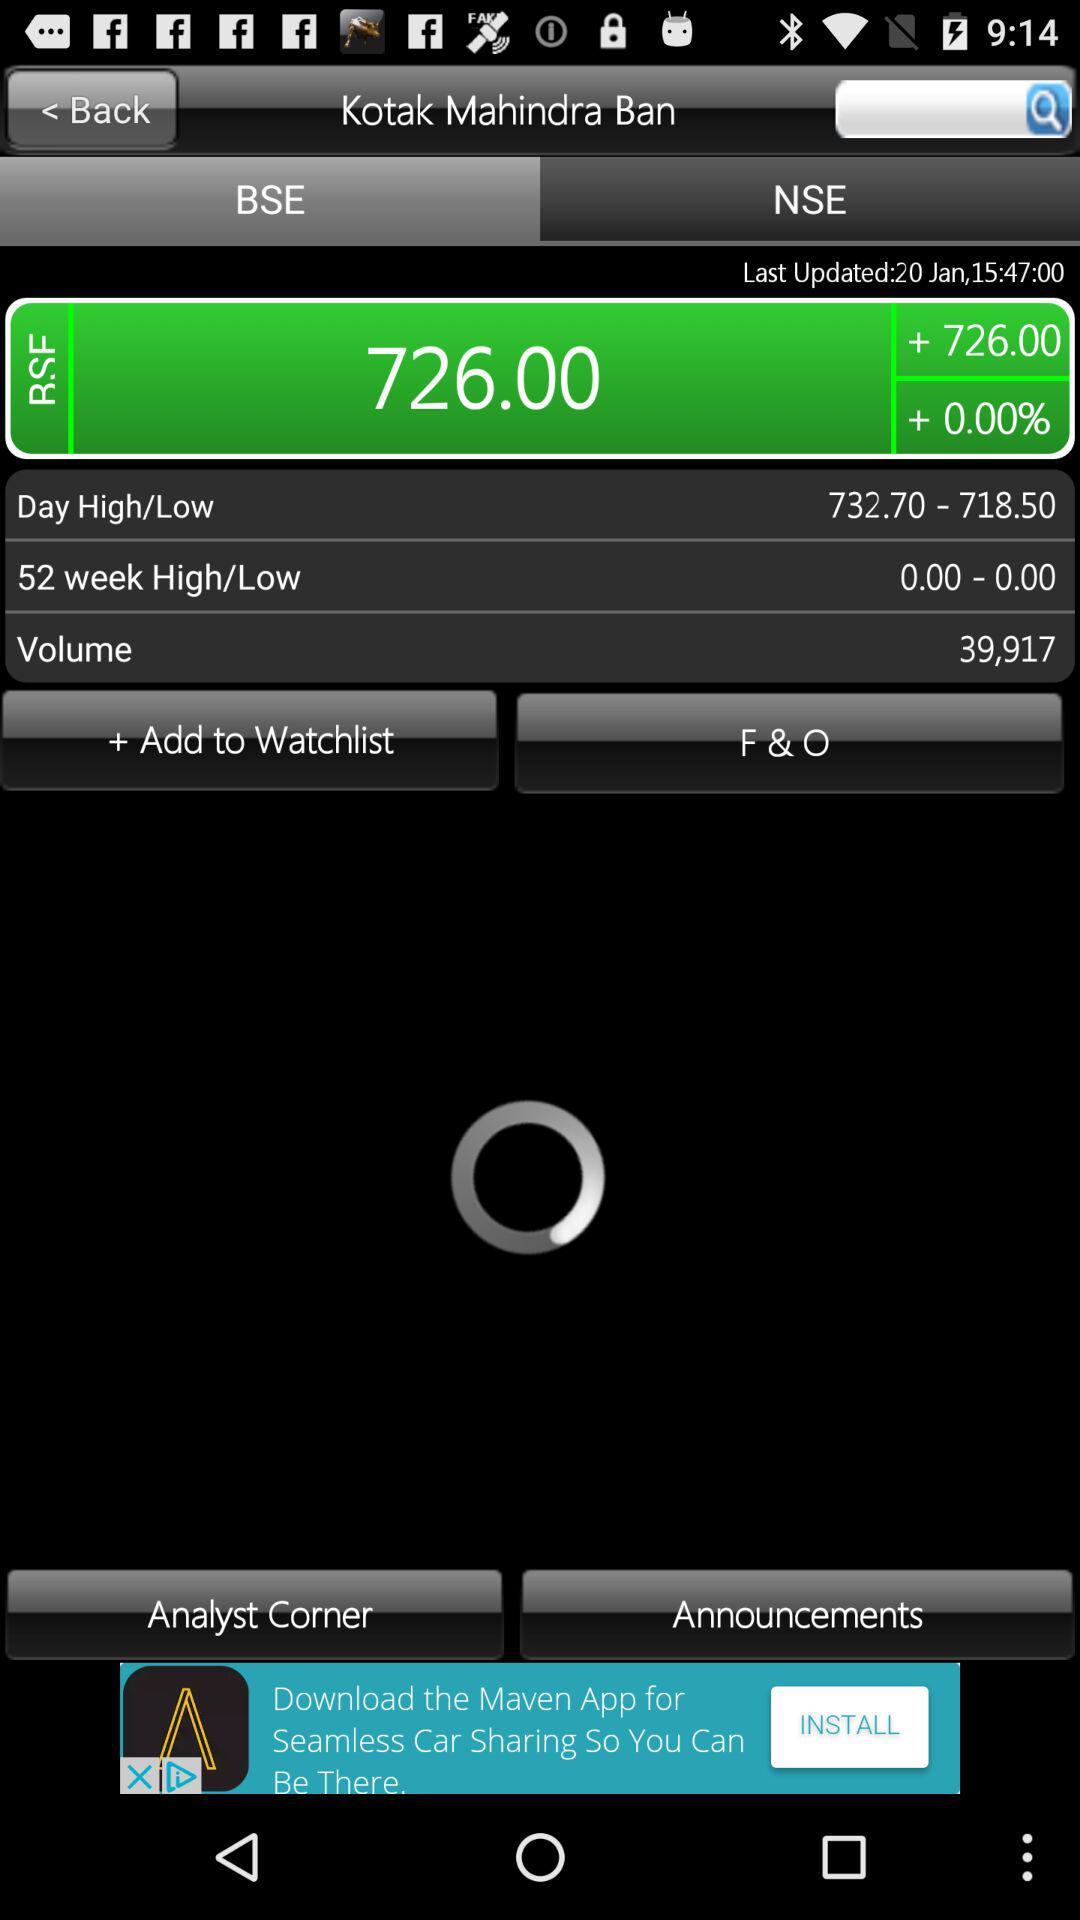What is the stock price of "Kotak Mahindra Ban"? The stock price of "Kotak Mahindra Ban" is 726.00. 